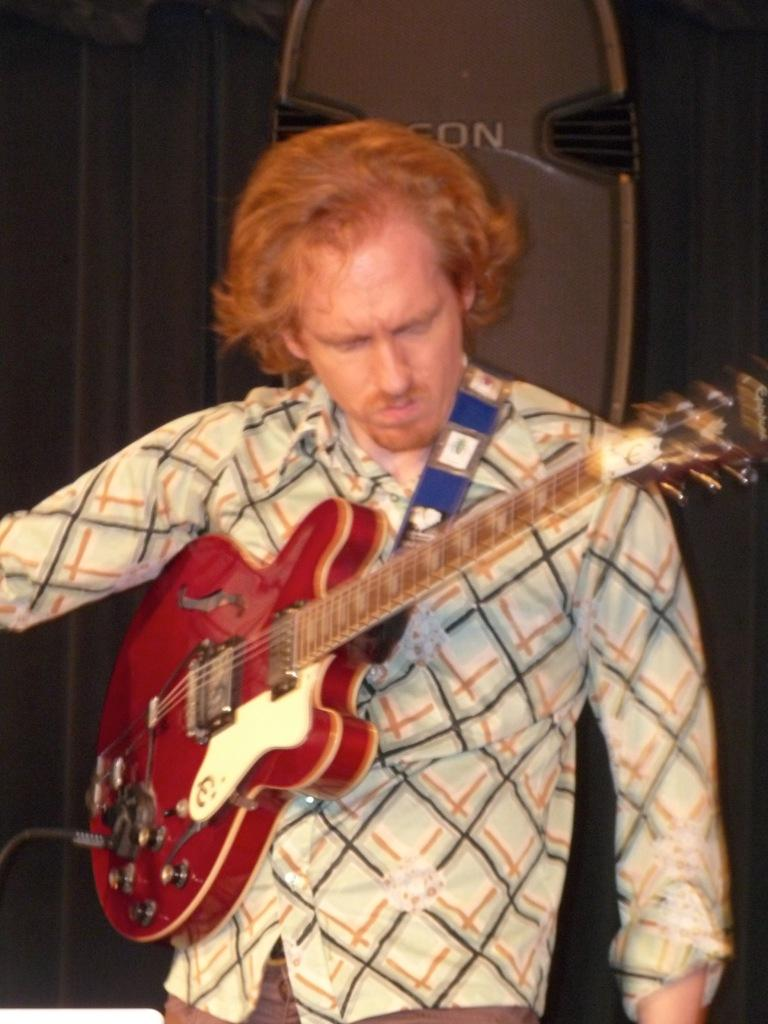What is the main subject of the image? The main subject of the image is a man. What is the man doing in the image? The man is standing in the image. What object is the man holding in the image? The man is holding a guitar in the image. What type of camp can be seen in the background of the image? There is no camp visible in the image; it only features a man standing and holding a guitar. 